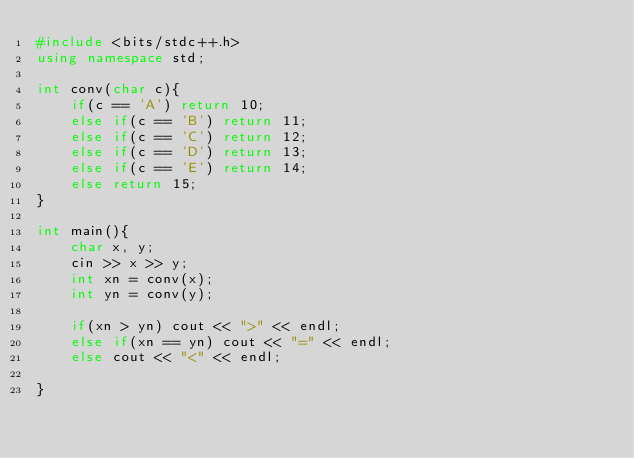<code> <loc_0><loc_0><loc_500><loc_500><_C++_>#include <bits/stdc++.h>
using namespace std;

int conv(char c){
    if(c == 'A') return 10;
    else if(c == 'B') return 11;
    else if(c == 'C') return 12;
    else if(c == 'D') return 13;
    else if(c == 'E') return 14;
    else return 15;
}

int main(){
    char x, y;
    cin >> x >> y;
    int xn = conv(x);
    int yn = conv(y);

    if(xn > yn) cout << ">" << endl;
    else if(xn == yn) cout << "=" << endl;
    else cout << "<" << endl;

}</code> 